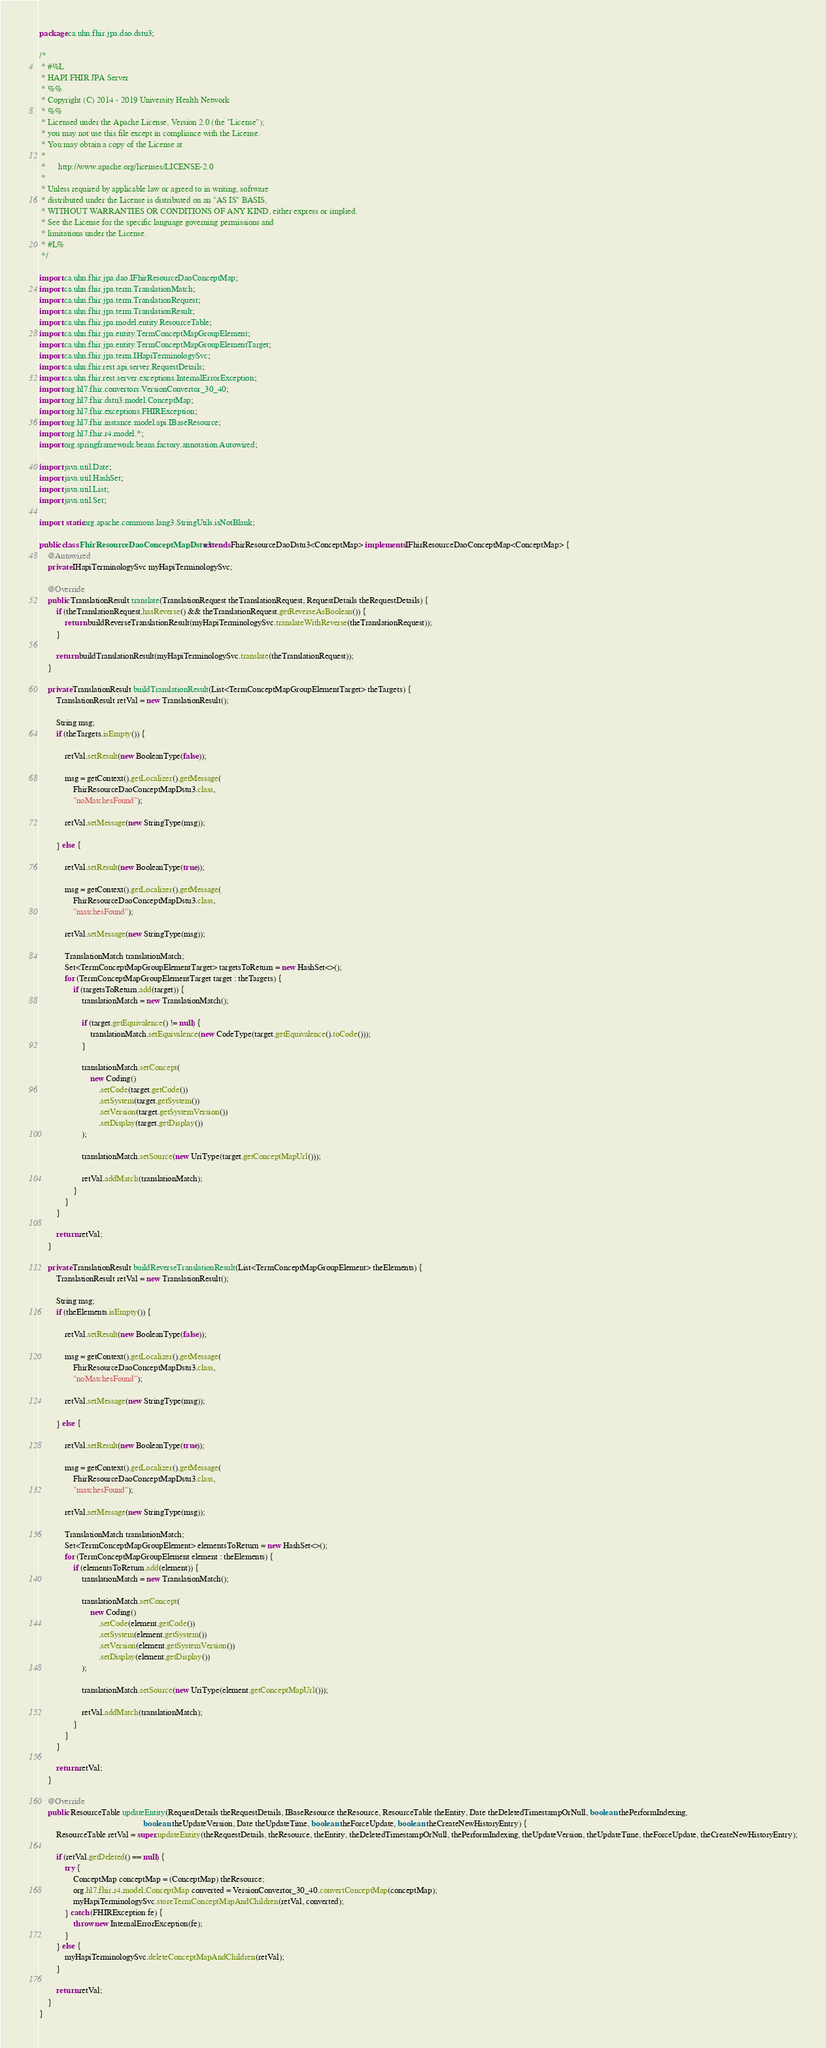Convert code to text. <code><loc_0><loc_0><loc_500><loc_500><_Java_>package ca.uhn.fhir.jpa.dao.dstu3;

/*
 * #%L
 * HAPI FHIR JPA Server
 * %%
 * Copyright (C) 2014 - 2019 University Health Network
 * %%
 * Licensed under the Apache License, Version 2.0 (the "License");
 * you may not use this file except in compliance with the License.
 * You may obtain a copy of the License at
 *
 *      http://www.apache.org/licenses/LICENSE-2.0
 *
 * Unless required by applicable law or agreed to in writing, software
 * distributed under the License is distributed on an "AS IS" BASIS,
 * WITHOUT WARRANTIES OR CONDITIONS OF ANY KIND, either express or implied.
 * See the License for the specific language governing permissions and
 * limitations under the License.
 * #L%
 */

import ca.uhn.fhir.jpa.dao.IFhirResourceDaoConceptMap;
import ca.uhn.fhir.jpa.term.TranslationMatch;
import ca.uhn.fhir.jpa.term.TranslationRequest;
import ca.uhn.fhir.jpa.term.TranslationResult;
import ca.uhn.fhir.jpa.model.entity.ResourceTable;
import ca.uhn.fhir.jpa.entity.TermConceptMapGroupElement;
import ca.uhn.fhir.jpa.entity.TermConceptMapGroupElementTarget;
import ca.uhn.fhir.jpa.term.IHapiTerminologySvc;
import ca.uhn.fhir.rest.api.server.RequestDetails;
import ca.uhn.fhir.rest.server.exceptions.InternalErrorException;
import org.hl7.fhir.convertors.VersionConvertor_30_40;
import org.hl7.fhir.dstu3.model.ConceptMap;
import org.hl7.fhir.exceptions.FHIRException;
import org.hl7.fhir.instance.model.api.IBaseResource;
import org.hl7.fhir.r4.model.*;
import org.springframework.beans.factory.annotation.Autowired;

import java.util.Date;
import java.util.HashSet;
import java.util.List;
import java.util.Set;

import static org.apache.commons.lang3.StringUtils.isNotBlank;

public class FhirResourceDaoConceptMapDstu3 extends FhirResourceDaoDstu3<ConceptMap> implements IFhirResourceDaoConceptMap<ConceptMap> {
	@Autowired
	private IHapiTerminologySvc myHapiTerminologySvc;

	@Override
	public TranslationResult translate(TranslationRequest theTranslationRequest, RequestDetails theRequestDetails) {
		if (theTranslationRequest.hasReverse() && theTranslationRequest.getReverseAsBoolean()) {
			return buildReverseTranslationResult(myHapiTerminologySvc.translateWithReverse(theTranslationRequest));
		}

		return buildTranslationResult(myHapiTerminologySvc.translate(theTranslationRequest));
	}

	private TranslationResult buildTranslationResult(List<TermConceptMapGroupElementTarget> theTargets) {
		TranslationResult retVal = new TranslationResult();

		String msg;
		if (theTargets.isEmpty()) {

			retVal.setResult(new BooleanType(false));

			msg = getContext().getLocalizer().getMessage(
				FhirResourceDaoConceptMapDstu3.class,
				"noMatchesFound");

			retVal.setMessage(new StringType(msg));

		} else {

			retVal.setResult(new BooleanType(true));

			msg = getContext().getLocalizer().getMessage(
				FhirResourceDaoConceptMapDstu3.class,
				"matchesFound");

			retVal.setMessage(new StringType(msg));

			TranslationMatch translationMatch;
			Set<TermConceptMapGroupElementTarget> targetsToReturn = new HashSet<>();
			for (TermConceptMapGroupElementTarget target : theTargets) {
				if (targetsToReturn.add(target)) {
					translationMatch = new TranslationMatch();

					if (target.getEquivalence() != null) {
						translationMatch.setEquivalence(new CodeType(target.getEquivalence().toCode()));
					}

					translationMatch.setConcept(
						new Coding()
							.setCode(target.getCode())
							.setSystem(target.getSystem())
							.setVersion(target.getSystemVersion())
							.setDisplay(target.getDisplay())
					);

					translationMatch.setSource(new UriType(target.getConceptMapUrl()));

					retVal.addMatch(translationMatch);
				}
			}
		}

		return retVal;
	}

	private TranslationResult buildReverseTranslationResult(List<TermConceptMapGroupElement> theElements) {
		TranslationResult retVal = new TranslationResult();

		String msg;
		if (theElements.isEmpty()) {

			retVal.setResult(new BooleanType(false));

			msg = getContext().getLocalizer().getMessage(
				FhirResourceDaoConceptMapDstu3.class,
				"noMatchesFound");

			retVal.setMessage(new StringType(msg));

		} else {

			retVal.setResult(new BooleanType(true));

			msg = getContext().getLocalizer().getMessage(
				FhirResourceDaoConceptMapDstu3.class,
				"matchesFound");

			retVal.setMessage(new StringType(msg));

			TranslationMatch translationMatch;
			Set<TermConceptMapGroupElement> elementsToReturn = new HashSet<>();
			for (TermConceptMapGroupElement element : theElements) {
				if (elementsToReturn.add(element)) {
					translationMatch = new TranslationMatch();

					translationMatch.setConcept(
						new Coding()
							.setCode(element.getCode())
							.setSystem(element.getSystem())
							.setVersion(element.getSystemVersion())
							.setDisplay(element.getDisplay())
					);

					translationMatch.setSource(new UriType(element.getConceptMapUrl()));

					retVal.addMatch(translationMatch);
				}
			}
		}

		return retVal;
	}

	@Override
	public ResourceTable updateEntity(RequestDetails theRequestDetails, IBaseResource theResource, ResourceTable theEntity, Date theDeletedTimestampOrNull, boolean thePerformIndexing,
												 boolean theUpdateVersion, Date theUpdateTime, boolean theForceUpdate, boolean theCreateNewHistoryEntry) {
		ResourceTable retVal = super.updateEntity(theRequestDetails, theResource, theEntity, theDeletedTimestampOrNull, thePerformIndexing, theUpdateVersion, theUpdateTime, theForceUpdate, theCreateNewHistoryEntry);

		if (retVal.getDeleted() == null) {
			try {
				ConceptMap conceptMap = (ConceptMap) theResource;
				org.hl7.fhir.r4.model.ConceptMap converted = VersionConvertor_30_40.convertConceptMap(conceptMap);
				myHapiTerminologySvc.storeTermConceptMapAndChildren(retVal, converted);
			} catch (FHIRException fe) {
				throw new InternalErrorException(fe);
			}
		} else {
			myHapiTerminologySvc.deleteConceptMapAndChildren(retVal);
		}

		return retVal;
	}
}
</code> 